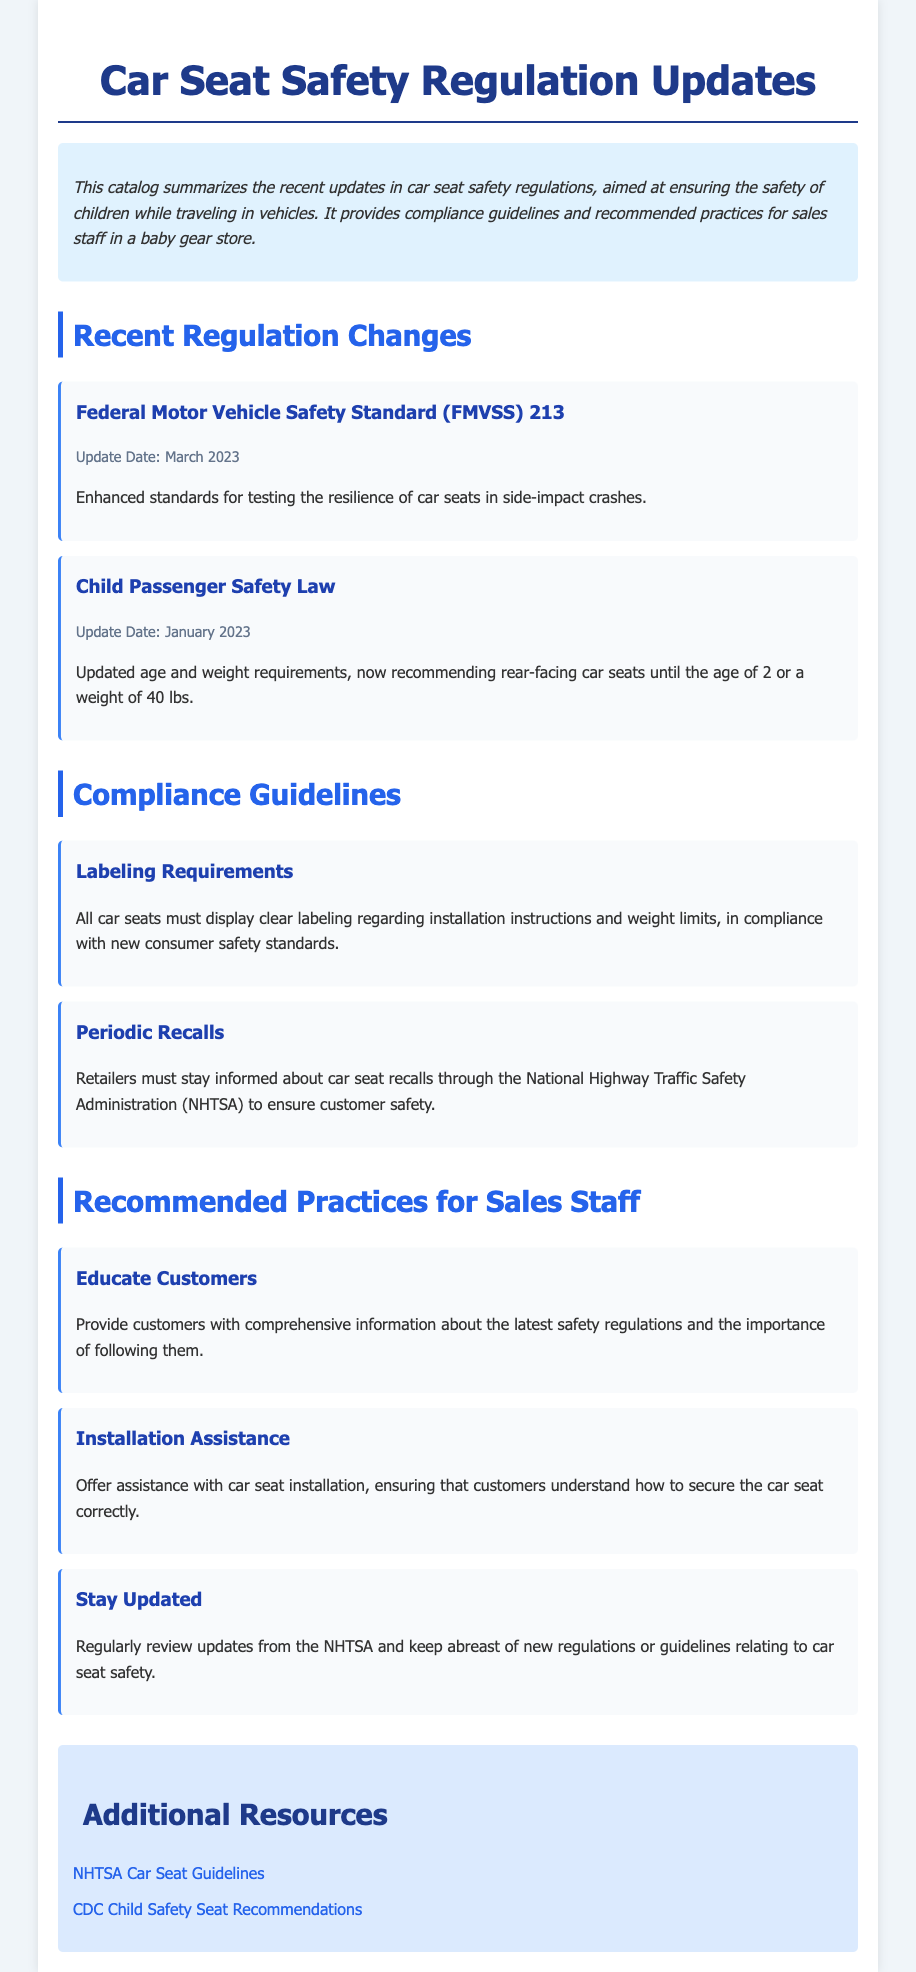What is the update date for FMVSS 213? The FMVSS 213 update date is specified in the regulations section as March 2023.
Answer: March 2023 What are the new weight requirements for rear-facing car seats? The updated requirements for rear-facing car seats, as per the Child Passenger Safety Law, are stated as 40 lbs.
Answer: 40 lbs What is a primary compliance guideline for car seats? The guidelines specify that all car seats must display clear labeling regarding installation instructions and weight limits.
Answer: Labeling Requirements What is one recommended practice for sales staff? The document lists multiple recommended practices for sales staff, including Educate Customers.
Answer: Educate Customers Which organization must retailers stay informed about for recalls? The necessary organization mentioned for recalls is the National Highway Traffic Safety Administration.
Answer: National Highway Traffic Safety Administration How often should sales staff review updates from the NHTSA? The recommended practice suggests that sales staff should regularly review updates.
Answer: Regularly What is the main focus of the catalog? The catalog summarizes updates in car seat safety regulations aimed at ensuring children's safety while traveling.
Answer: Car seat safety regulations When was the Child Passenger Safety Law updated? The update date provided for the Child Passenger Safety Law is January 2023.
Answer: January 2023 What does the document provide for customers? The document provides comprehensive information about the latest safety regulations and the importance of following them.
Answer: Comprehensive information 